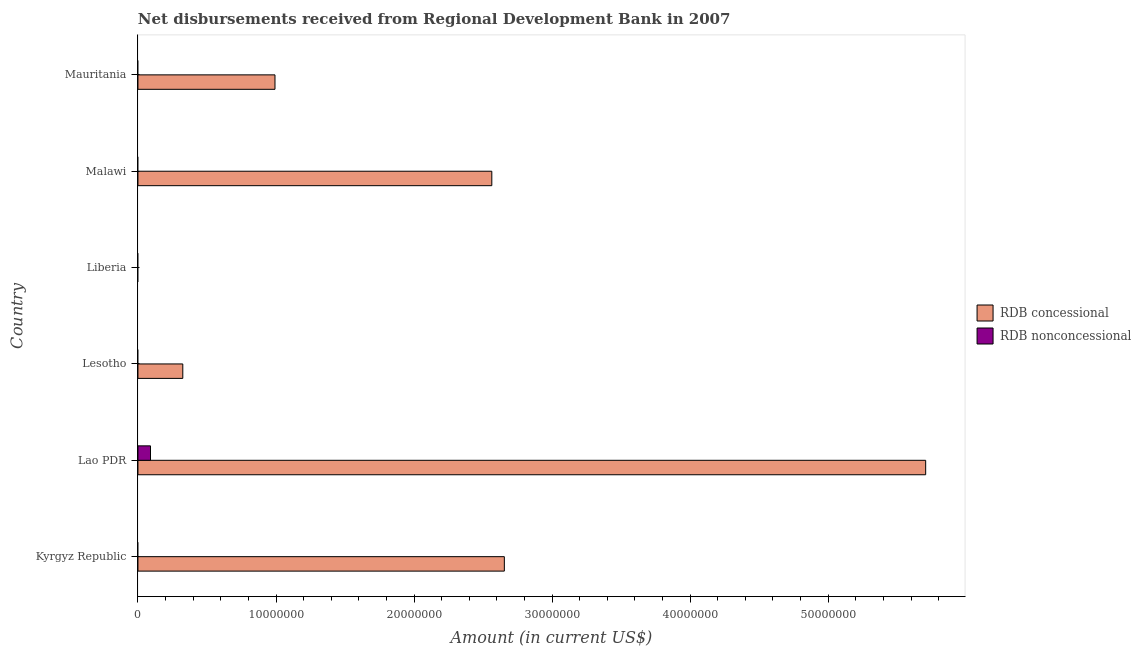How many different coloured bars are there?
Ensure brevity in your answer.  2. Are the number of bars on each tick of the Y-axis equal?
Your answer should be compact. No. How many bars are there on the 5th tick from the top?
Your response must be concise. 2. What is the label of the 6th group of bars from the top?
Make the answer very short. Kyrgyz Republic. In how many cases, is the number of bars for a given country not equal to the number of legend labels?
Offer a terse response. 5. What is the net non concessional disbursements from rdb in Malawi?
Offer a very short reply. 0. Across all countries, what is the maximum net concessional disbursements from rdb?
Your answer should be compact. 5.71e+07. In which country was the net concessional disbursements from rdb maximum?
Offer a terse response. Lao PDR. What is the total net concessional disbursements from rdb in the graph?
Give a very brief answer. 1.22e+08. What is the difference between the net concessional disbursements from rdb in Lao PDR and that in Malawi?
Offer a terse response. 3.14e+07. What is the average net non concessional disbursements from rdb per country?
Your answer should be very brief. 1.52e+05. What is the difference between the net concessional disbursements from rdb and net non concessional disbursements from rdb in Lao PDR?
Keep it short and to the point. 5.62e+07. What is the ratio of the net concessional disbursements from rdb in Malawi to that in Mauritania?
Keep it short and to the point. 2.58. What is the difference between the highest and the second highest net concessional disbursements from rdb?
Your response must be concise. 3.05e+07. What is the difference between the highest and the lowest net non concessional disbursements from rdb?
Give a very brief answer. 9.09e+05. In how many countries, is the net non concessional disbursements from rdb greater than the average net non concessional disbursements from rdb taken over all countries?
Ensure brevity in your answer.  1. Where does the legend appear in the graph?
Your response must be concise. Center right. What is the title of the graph?
Keep it short and to the point. Net disbursements received from Regional Development Bank in 2007. Does "Number of departures" appear as one of the legend labels in the graph?
Give a very brief answer. No. What is the Amount (in current US$) of RDB concessional in Kyrgyz Republic?
Your response must be concise. 2.65e+07. What is the Amount (in current US$) in RDB concessional in Lao PDR?
Offer a terse response. 5.71e+07. What is the Amount (in current US$) in RDB nonconcessional in Lao PDR?
Offer a very short reply. 9.09e+05. What is the Amount (in current US$) in RDB concessional in Lesotho?
Your response must be concise. 3.25e+06. What is the Amount (in current US$) of RDB nonconcessional in Lesotho?
Give a very brief answer. 0. What is the Amount (in current US$) in RDB nonconcessional in Liberia?
Give a very brief answer. 0. What is the Amount (in current US$) of RDB concessional in Malawi?
Provide a short and direct response. 2.56e+07. What is the Amount (in current US$) in RDB nonconcessional in Malawi?
Provide a succinct answer. 0. What is the Amount (in current US$) in RDB concessional in Mauritania?
Provide a short and direct response. 9.93e+06. Across all countries, what is the maximum Amount (in current US$) of RDB concessional?
Your answer should be compact. 5.71e+07. Across all countries, what is the maximum Amount (in current US$) of RDB nonconcessional?
Ensure brevity in your answer.  9.09e+05. Across all countries, what is the minimum Amount (in current US$) of RDB concessional?
Provide a short and direct response. 0. Across all countries, what is the minimum Amount (in current US$) of RDB nonconcessional?
Offer a terse response. 0. What is the total Amount (in current US$) in RDB concessional in the graph?
Make the answer very short. 1.22e+08. What is the total Amount (in current US$) of RDB nonconcessional in the graph?
Keep it short and to the point. 9.09e+05. What is the difference between the Amount (in current US$) in RDB concessional in Kyrgyz Republic and that in Lao PDR?
Give a very brief answer. -3.05e+07. What is the difference between the Amount (in current US$) of RDB concessional in Kyrgyz Republic and that in Lesotho?
Your answer should be very brief. 2.33e+07. What is the difference between the Amount (in current US$) of RDB concessional in Kyrgyz Republic and that in Malawi?
Provide a succinct answer. 9.07e+05. What is the difference between the Amount (in current US$) of RDB concessional in Kyrgyz Republic and that in Mauritania?
Offer a very short reply. 1.66e+07. What is the difference between the Amount (in current US$) in RDB concessional in Lao PDR and that in Lesotho?
Provide a short and direct response. 5.38e+07. What is the difference between the Amount (in current US$) in RDB concessional in Lao PDR and that in Malawi?
Give a very brief answer. 3.14e+07. What is the difference between the Amount (in current US$) of RDB concessional in Lao PDR and that in Mauritania?
Provide a succinct answer. 4.71e+07. What is the difference between the Amount (in current US$) of RDB concessional in Lesotho and that in Malawi?
Provide a short and direct response. -2.24e+07. What is the difference between the Amount (in current US$) of RDB concessional in Lesotho and that in Mauritania?
Your response must be concise. -6.68e+06. What is the difference between the Amount (in current US$) of RDB concessional in Malawi and that in Mauritania?
Provide a short and direct response. 1.57e+07. What is the difference between the Amount (in current US$) in RDB concessional in Kyrgyz Republic and the Amount (in current US$) in RDB nonconcessional in Lao PDR?
Give a very brief answer. 2.56e+07. What is the average Amount (in current US$) in RDB concessional per country?
Give a very brief answer. 2.04e+07. What is the average Amount (in current US$) of RDB nonconcessional per country?
Your response must be concise. 1.52e+05. What is the difference between the Amount (in current US$) of RDB concessional and Amount (in current US$) of RDB nonconcessional in Lao PDR?
Give a very brief answer. 5.62e+07. What is the ratio of the Amount (in current US$) in RDB concessional in Kyrgyz Republic to that in Lao PDR?
Your response must be concise. 0.47. What is the ratio of the Amount (in current US$) in RDB concessional in Kyrgyz Republic to that in Lesotho?
Your answer should be compact. 8.17. What is the ratio of the Amount (in current US$) in RDB concessional in Kyrgyz Republic to that in Malawi?
Ensure brevity in your answer.  1.04. What is the ratio of the Amount (in current US$) of RDB concessional in Kyrgyz Republic to that in Mauritania?
Your answer should be compact. 2.67. What is the ratio of the Amount (in current US$) of RDB concessional in Lao PDR to that in Lesotho?
Offer a very short reply. 17.57. What is the ratio of the Amount (in current US$) in RDB concessional in Lao PDR to that in Malawi?
Give a very brief answer. 2.23. What is the ratio of the Amount (in current US$) of RDB concessional in Lao PDR to that in Mauritania?
Offer a very short reply. 5.75. What is the ratio of the Amount (in current US$) in RDB concessional in Lesotho to that in Malawi?
Your answer should be compact. 0.13. What is the ratio of the Amount (in current US$) in RDB concessional in Lesotho to that in Mauritania?
Make the answer very short. 0.33. What is the ratio of the Amount (in current US$) of RDB concessional in Malawi to that in Mauritania?
Give a very brief answer. 2.58. What is the difference between the highest and the second highest Amount (in current US$) in RDB concessional?
Provide a succinct answer. 3.05e+07. What is the difference between the highest and the lowest Amount (in current US$) in RDB concessional?
Your response must be concise. 5.71e+07. What is the difference between the highest and the lowest Amount (in current US$) of RDB nonconcessional?
Your response must be concise. 9.09e+05. 